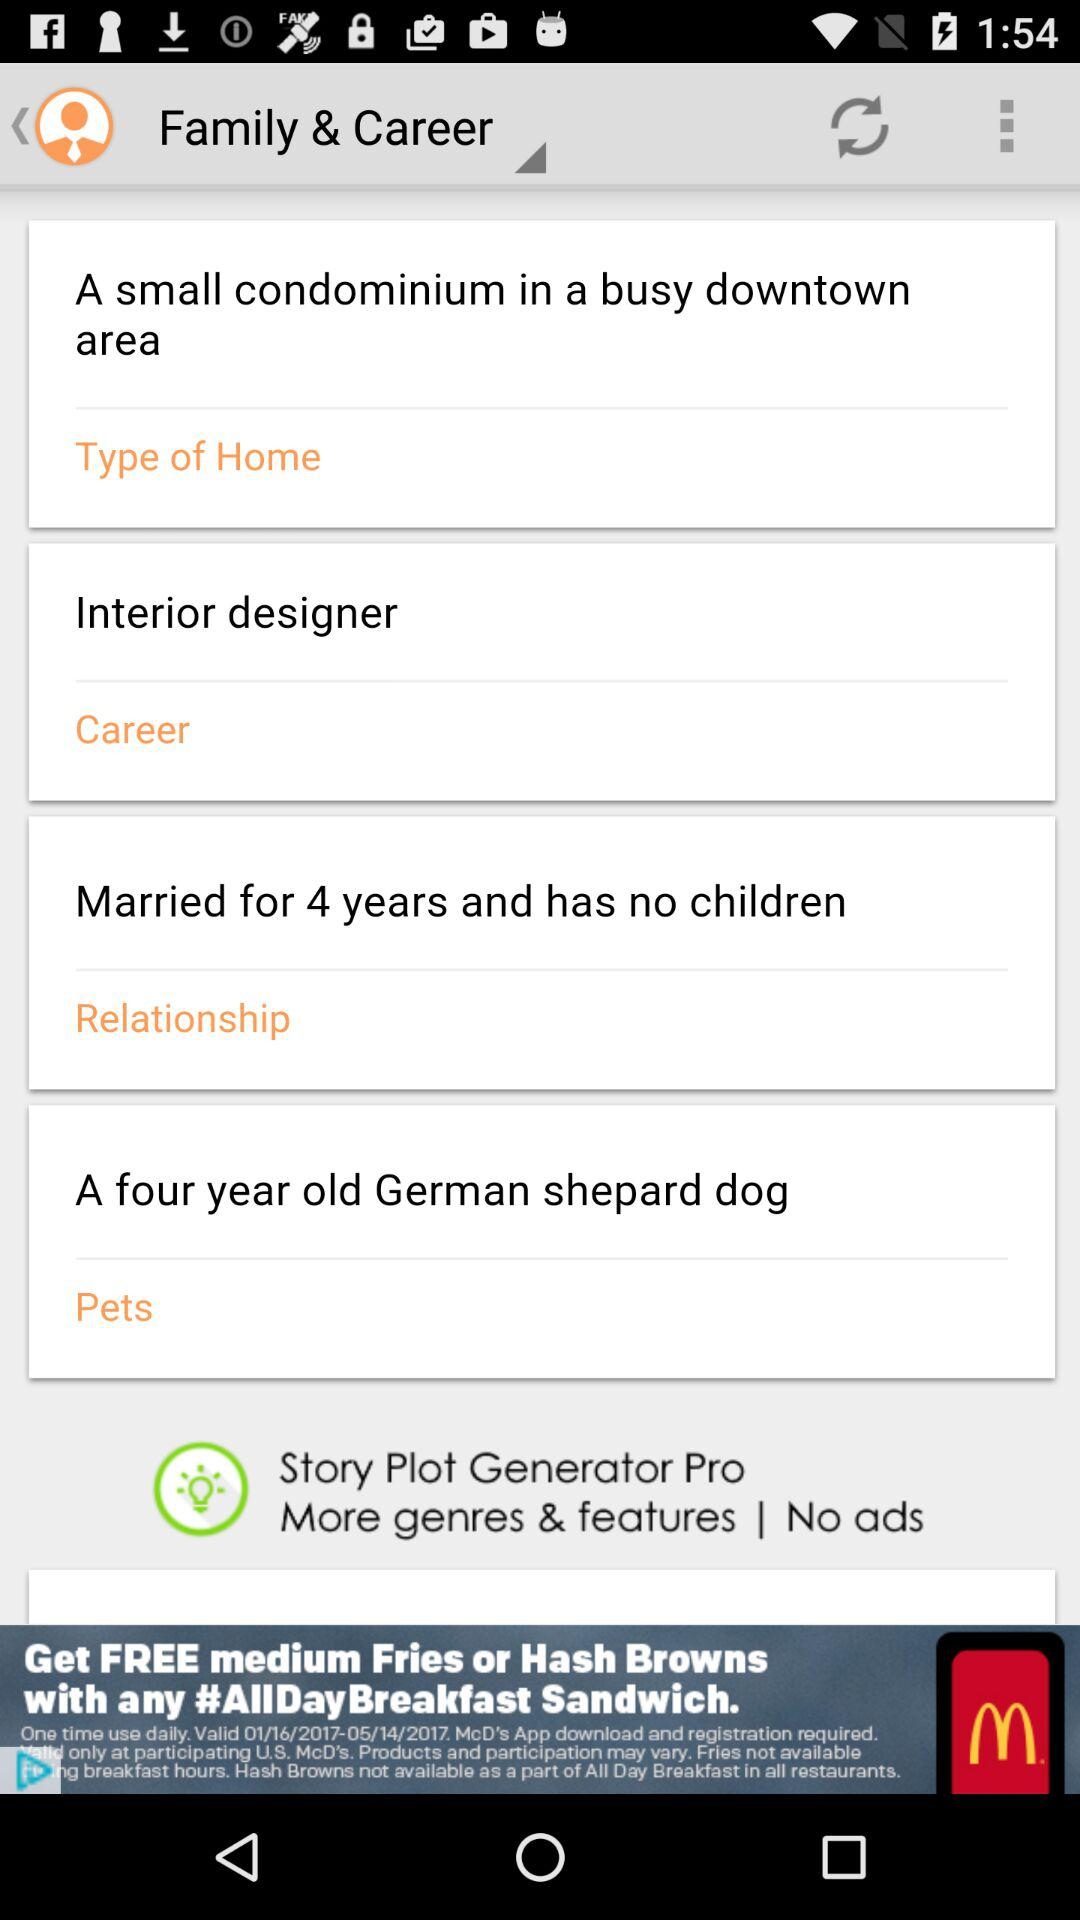Are there any children? There are no children. 